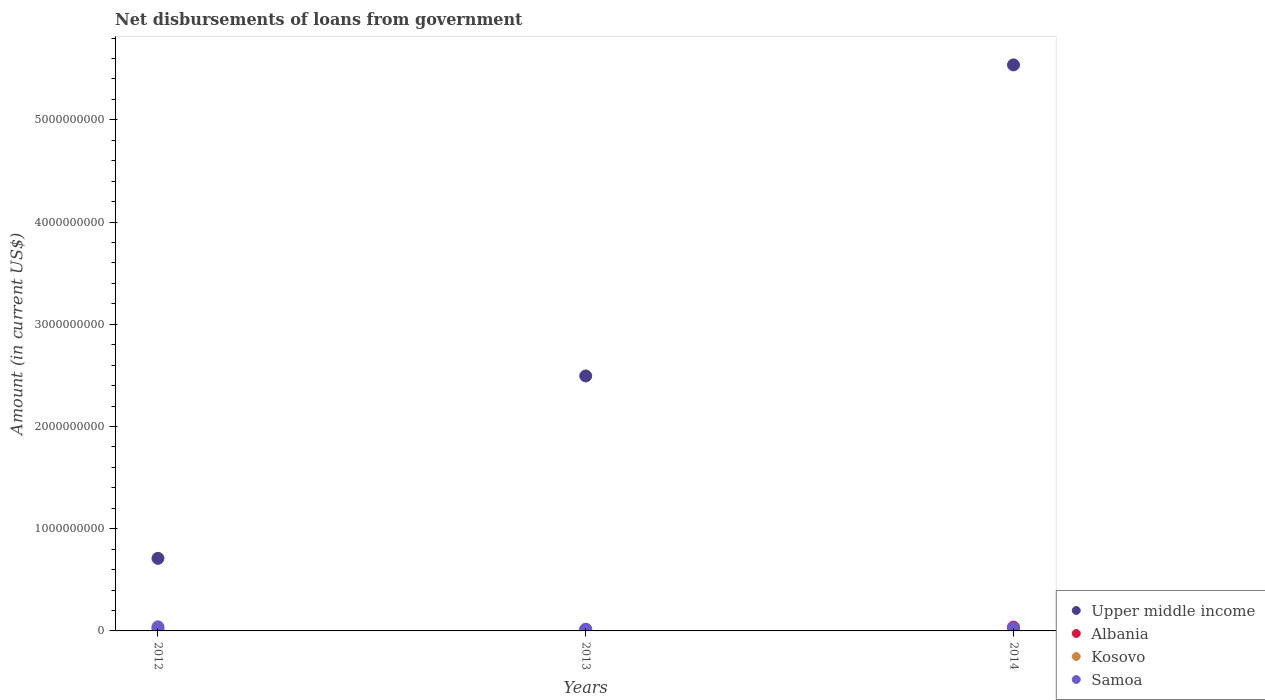Is the number of dotlines equal to the number of legend labels?
Your answer should be compact. Yes. What is the amount of loan disbursed from government in Kosovo in 2013?
Make the answer very short. 2.49e+06. Across all years, what is the maximum amount of loan disbursed from government in Samoa?
Keep it short and to the point. 4.00e+07. Across all years, what is the minimum amount of loan disbursed from government in Upper middle income?
Keep it short and to the point. 7.10e+08. In which year was the amount of loan disbursed from government in Upper middle income maximum?
Your answer should be very brief. 2014. In which year was the amount of loan disbursed from government in Kosovo minimum?
Your answer should be compact. 2012. What is the total amount of loan disbursed from government in Kosovo in the graph?
Provide a succinct answer. 1.25e+07. What is the difference between the amount of loan disbursed from government in Kosovo in 2012 and that in 2013?
Offer a terse response. -2.31e+06. What is the difference between the amount of loan disbursed from government in Albania in 2013 and the amount of loan disbursed from government in Samoa in 2012?
Keep it short and to the point. -2.71e+07. What is the average amount of loan disbursed from government in Albania per year?
Offer a terse response. 2.31e+07. In the year 2014, what is the difference between the amount of loan disbursed from government in Samoa and amount of loan disbursed from government in Albania?
Your answer should be very brief. -9.34e+06. In how many years, is the amount of loan disbursed from government in Samoa greater than 2000000000 US$?
Give a very brief answer. 0. What is the ratio of the amount of loan disbursed from government in Upper middle income in 2013 to that in 2014?
Ensure brevity in your answer.  0.45. Is the amount of loan disbursed from government in Albania in 2013 less than that in 2014?
Make the answer very short. Yes. What is the difference between the highest and the second highest amount of loan disbursed from government in Albania?
Your answer should be compact. 1.79e+07. What is the difference between the highest and the lowest amount of loan disbursed from government in Kosovo?
Provide a short and direct response. 9.67e+06. Is the sum of the amount of loan disbursed from government in Samoa in 2012 and 2014 greater than the maximum amount of loan disbursed from government in Upper middle income across all years?
Keep it short and to the point. No. Is the amount of loan disbursed from government in Albania strictly less than the amount of loan disbursed from government in Kosovo over the years?
Give a very brief answer. No. How many dotlines are there?
Make the answer very short. 4. How many years are there in the graph?
Ensure brevity in your answer.  3. Are the values on the major ticks of Y-axis written in scientific E-notation?
Keep it short and to the point. No. Does the graph contain any zero values?
Your response must be concise. No. Does the graph contain grids?
Give a very brief answer. No. How many legend labels are there?
Provide a short and direct response. 4. How are the legend labels stacked?
Provide a short and direct response. Vertical. What is the title of the graph?
Keep it short and to the point. Net disbursements of loans from government. What is the label or title of the X-axis?
Offer a terse response. Years. What is the label or title of the Y-axis?
Your response must be concise. Amount (in current US$). What is the Amount (in current US$) in Upper middle income in 2012?
Ensure brevity in your answer.  7.10e+08. What is the Amount (in current US$) of Albania in 2012?
Keep it short and to the point. 1.92e+07. What is the Amount (in current US$) in Kosovo in 2012?
Your response must be concise. 1.78e+05. What is the Amount (in current US$) in Samoa in 2012?
Ensure brevity in your answer.  4.00e+07. What is the Amount (in current US$) of Upper middle income in 2013?
Provide a succinct answer. 2.49e+09. What is the Amount (in current US$) in Albania in 2013?
Provide a succinct answer. 1.30e+07. What is the Amount (in current US$) of Kosovo in 2013?
Provide a succinct answer. 2.49e+06. What is the Amount (in current US$) of Samoa in 2013?
Make the answer very short. 1.65e+07. What is the Amount (in current US$) in Upper middle income in 2014?
Ensure brevity in your answer.  5.54e+09. What is the Amount (in current US$) in Albania in 2014?
Your answer should be compact. 3.71e+07. What is the Amount (in current US$) in Kosovo in 2014?
Offer a terse response. 9.84e+06. What is the Amount (in current US$) in Samoa in 2014?
Make the answer very short. 2.78e+07. Across all years, what is the maximum Amount (in current US$) of Upper middle income?
Your answer should be compact. 5.54e+09. Across all years, what is the maximum Amount (in current US$) in Albania?
Ensure brevity in your answer.  3.71e+07. Across all years, what is the maximum Amount (in current US$) in Kosovo?
Offer a very short reply. 9.84e+06. Across all years, what is the maximum Amount (in current US$) of Samoa?
Give a very brief answer. 4.00e+07. Across all years, what is the minimum Amount (in current US$) in Upper middle income?
Your answer should be very brief. 7.10e+08. Across all years, what is the minimum Amount (in current US$) of Albania?
Make the answer very short. 1.30e+07. Across all years, what is the minimum Amount (in current US$) of Kosovo?
Your response must be concise. 1.78e+05. Across all years, what is the minimum Amount (in current US$) in Samoa?
Make the answer very short. 1.65e+07. What is the total Amount (in current US$) in Upper middle income in the graph?
Offer a terse response. 8.74e+09. What is the total Amount (in current US$) in Albania in the graph?
Provide a short and direct response. 6.93e+07. What is the total Amount (in current US$) of Kosovo in the graph?
Offer a very short reply. 1.25e+07. What is the total Amount (in current US$) of Samoa in the graph?
Offer a terse response. 8.43e+07. What is the difference between the Amount (in current US$) in Upper middle income in 2012 and that in 2013?
Provide a short and direct response. -1.78e+09. What is the difference between the Amount (in current US$) in Albania in 2012 and that in 2013?
Make the answer very short. 6.24e+06. What is the difference between the Amount (in current US$) of Kosovo in 2012 and that in 2013?
Your answer should be compact. -2.31e+06. What is the difference between the Amount (in current US$) in Samoa in 2012 and that in 2013?
Ensure brevity in your answer.  2.36e+07. What is the difference between the Amount (in current US$) in Upper middle income in 2012 and that in 2014?
Ensure brevity in your answer.  -4.83e+09. What is the difference between the Amount (in current US$) of Albania in 2012 and that in 2014?
Offer a very short reply. -1.79e+07. What is the difference between the Amount (in current US$) of Kosovo in 2012 and that in 2014?
Your answer should be compact. -9.67e+06. What is the difference between the Amount (in current US$) of Samoa in 2012 and that in 2014?
Make the answer very short. 1.22e+07. What is the difference between the Amount (in current US$) in Upper middle income in 2013 and that in 2014?
Keep it short and to the point. -3.04e+09. What is the difference between the Amount (in current US$) in Albania in 2013 and that in 2014?
Your answer should be compact. -2.42e+07. What is the difference between the Amount (in current US$) of Kosovo in 2013 and that in 2014?
Keep it short and to the point. -7.35e+06. What is the difference between the Amount (in current US$) in Samoa in 2013 and that in 2014?
Offer a very short reply. -1.13e+07. What is the difference between the Amount (in current US$) of Upper middle income in 2012 and the Amount (in current US$) of Albania in 2013?
Your response must be concise. 6.97e+08. What is the difference between the Amount (in current US$) in Upper middle income in 2012 and the Amount (in current US$) in Kosovo in 2013?
Your response must be concise. 7.08e+08. What is the difference between the Amount (in current US$) of Upper middle income in 2012 and the Amount (in current US$) of Samoa in 2013?
Keep it short and to the point. 6.94e+08. What is the difference between the Amount (in current US$) of Albania in 2012 and the Amount (in current US$) of Kosovo in 2013?
Offer a very short reply. 1.67e+07. What is the difference between the Amount (in current US$) of Albania in 2012 and the Amount (in current US$) of Samoa in 2013?
Keep it short and to the point. 2.74e+06. What is the difference between the Amount (in current US$) of Kosovo in 2012 and the Amount (in current US$) of Samoa in 2013?
Your answer should be compact. -1.63e+07. What is the difference between the Amount (in current US$) in Upper middle income in 2012 and the Amount (in current US$) in Albania in 2014?
Keep it short and to the point. 6.73e+08. What is the difference between the Amount (in current US$) of Upper middle income in 2012 and the Amount (in current US$) of Kosovo in 2014?
Give a very brief answer. 7.00e+08. What is the difference between the Amount (in current US$) of Upper middle income in 2012 and the Amount (in current US$) of Samoa in 2014?
Make the answer very short. 6.82e+08. What is the difference between the Amount (in current US$) of Albania in 2012 and the Amount (in current US$) of Kosovo in 2014?
Provide a succinct answer. 9.35e+06. What is the difference between the Amount (in current US$) of Albania in 2012 and the Amount (in current US$) of Samoa in 2014?
Provide a succinct answer. -8.60e+06. What is the difference between the Amount (in current US$) of Kosovo in 2012 and the Amount (in current US$) of Samoa in 2014?
Offer a very short reply. -2.76e+07. What is the difference between the Amount (in current US$) in Upper middle income in 2013 and the Amount (in current US$) in Albania in 2014?
Offer a terse response. 2.46e+09. What is the difference between the Amount (in current US$) of Upper middle income in 2013 and the Amount (in current US$) of Kosovo in 2014?
Your answer should be compact. 2.48e+09. What is the difference between the Amount (in current US$) in Upper middle income in 2013 and the Amount (in current US$) in Samoa in 2014?
Provide a short and direct response. 2.47e+09. What is the difference between the Amount (in current US$) in Albania in 2013 and the Amount (in current US$) in Kosovo in 2014?
Provide a short and direct response. 3.12e+06. What is the difference between the Amount (in current US$) of Albania in 2013 and the Amount (in current US$) of Samoa in 2014?
Give a very brief answer. -1.48e+07. What is the difference between the Amount (in current US$) in Kosovo in 2013 and the Amount (in current US$) in Samoa in 2014?
Ensure brevity in your answer.  -2.53e+07. What is the average Amount (in current US$) in Upper middle income per year?
Give a very brief answer. 2.91e+09. What is the average Amount (in current US$) of Albania per year?
Your answer should be very brief. 2.31e+07. What is the average Amount (in current US$) in Kosovo per year?
Your response must be concise. 4.17e+06. What is the average Amount (in current US$) of Samoa per year?
Your answer should be very brief. 2.81e+07. In the year 2012, what is the difference between the Amount (in current US$) in Upper middle income and Amount (in current US$) in Albania?
Provide a short and direct response. 6.91e+08. In the year 2012, what is the difference between the Amount (in current US$) in Upper middle income and Amount (in current US$) in Kosovo?
Keep it short and to the point. 7.10e+08. In the year 2012, what is the difference between the Amount (in current US$) in Upper middle income and Amount (in current US$) in Samoa?
Ensure brevity in your answer.  6.70e+08. In the year 2012, what is the difference between the Amount (in current US$) in Albania and Amount (in current US$) in Kosovo?
Provide a succinct answer. 1.90e+07. In the year 2012, what is the difference between the Amount (in current US$) in Albania and Amount (in current US$) in Samoa?
Your answer should be very brief. -2.08e+07. In the year 2012, what is the difference between the Amount (in current US$) of Kosovo and Amount (in current US$) of Samoa?
Ensure brevity in your answer.  -3.99e+07. In the year 2013, what is the difference between the Amount (in current US$) in Upper middle income and Amount (in current US$) in Albania?
Offer a terse response. 2.48e+09. In the year 2013, what is the difference between the Amount (in current US$) in Upper middle income and Amount (in current US$) in Kosovo?
Keep it short and to the point. 2.49e+09. In the year 2013, what is the difference between the Amount (in current US$) of Upper middle income and Amount (in current US$) of Samoa?
Your answer should be compact. 2.48e+09. In the year 2013, what is the difference between the Amount (in current US$) in Albania and Amount (in current US$) in Kosovo?
Provide a succinct answer. 1.05e+07. In the year 2013, what is the difference between the Amount (in current US$) of Albania and Amount (in current US$) of Samoa?
Your response must be concise. -3.49e+06. In the year 2013, what is the difference between the Amount (in current US$) in Kosovo and Amount (in current US$) in Samoa?
Your response must be concise. -1.40e+07. In the year 2014, what is the difference between the Amount (in current US$) of Upper middle income and Amount (in current US$) of Albania?
Make the answer very short. 5.50e+09. In the year 2014, what is the difference between the Amount (in current US$) in Upper middle income and Amount (in current US$) in Kosovo?
Give a very brief answer. 5.53e+09. In the year 2014, what is the difference between the Amount (in current US$) in Upper middle income and Amount (in current US$) in Samoa?
Offer a very short reply. 5.51e+09. In the year 2014, what is the difference between the Amount (in current US$) of Albania and Amount (in current US$) of Kosovo?
Your answer should be very brief. 2.73e+07. In the year 2014, what is the difference between the Amount (in current US$) of Albania and Amount (in current US$) of Samoa?
Provide a short and direct response. 9.34e+06. In the year 2014, what is the difference between the Amount (in current US$) in Kosovo and Amount (in current US$) in Samoa?
Provide a succinct answer. -1.79e+07. What is the ratio of the Amount (in current US$) of Upper middle income in 2012 to that in 2013?
Give a very brief answer. 0.28. What is the ratio of the Amount (in current US$) in Albania in 2012 to that in 2013?
Make the answer very short. 1.48. What is the ratio of the Amount (in current US$) of Kosovo in 2012 to that in 2013?
Your response must be concise. 0.07. What is the ratio of the Amount (in current US$) in Samoa in 2012 to that in 2013?
Offer a very short reply. 2.43. What is the ratio of the Amount (in current US$) in Upper middle income in 2012 to that in 2014?
Your answer should be very brief. 0.13. What is the ratio of the Amount (in current US$) in Albania in 2012 to that in 2014?
Your answer should be compact. 0.52. What is the ratio of the Amount (in current US$) of Kosovo in 2012 to that in 2014?
Provide a succinct answer. 0.02. What is the ratio of the Amount (in current US$) in Samoa in 2012 to that in 2014?
Offer a terse response. 1.44. What is the ratio of the Amount (in current US$) in Upper middle income in 2013 to that in 2014?
Offer a very short reply. 0.45. What is the ratio of the Amount (in current US$) of Albania in 2013 to that in 2014?
Offer a very short reply. 0.35. What is the ratio of the Amount (in current US$) in Kosovo in 2013 to that in 2014?
Give a very brief answer. 0.25. What is the ratio of the Amount (in current US$) of Samoa in 2013 to that in 2014?
Ensure brevity in your answer.  0.59. What is the difference between the highest and the second highest Amount (in current US$) of Upper middle income?
Ensure brevity in your answer.  3.04e+09. What is the difference between the highest and the second highest Amount (in current US$) in Albania?
Provide a short and direct response. 1.79e+07. What is the difference between the highest and the second highest Amount (in current US$) of Kosovo?
Offer a very short reply. 7.35e+06. What is the difference between the highest and the second highest Amount (in current US$) of Samoa?
Ensure brevity in your answer.  1.22e+07. What is the difference between the highest and the lowest Amount (in current US$) in Upper middle income?
Keep it short and to the point. 4.83e+09. What is the difference between the highest and the lowest Amount (in current US$) in Albania?
Keep it short and to the point. 2.42e+07. What is the difference between the highest and the lowest Amount (in current US$) in Kosovo?
Offer a terse response. 9.67e+06. What is the difference between the highest and the lowest Amount (in current US$) in Samoa?
Ensure brevity in your answer.  2.36e+07. 